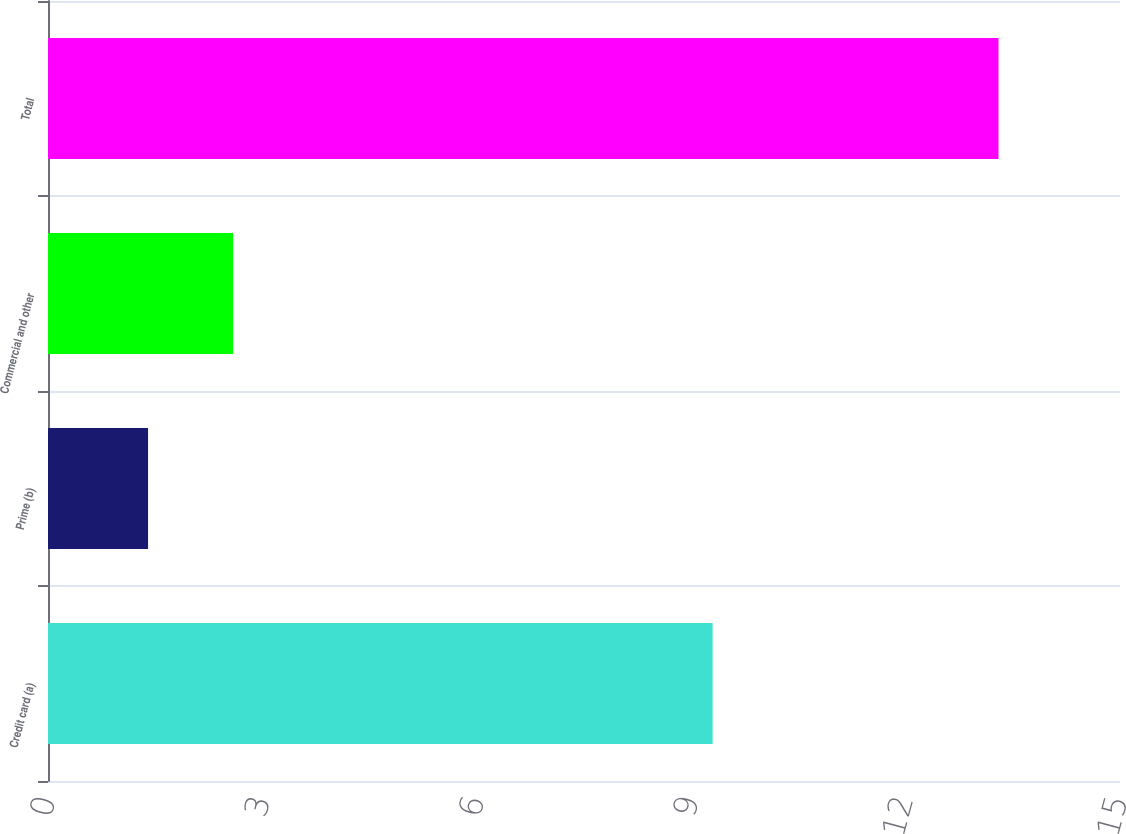Convert chart. <chart><loc_0><loc_0><loc_500><loc_500><bar_chart><fcel>Credit card (a)<fcel>Prime (b)<fcel>Commercial and other<fcel>Total<nl><fcel>9.3<fcel>1.4<fcel>2.59<fcel>13.3<nl></chart> 